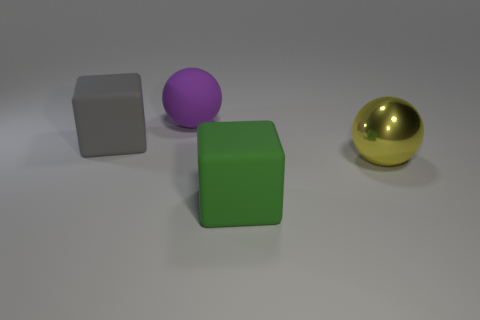There is a matte object that is on the right side of the gray block and in front of the large purple object; what color is it?
Your answer should be compact. Green. How big is the cube that is left of the big cube in front of the gray rubber block?
Offer a terse response. Large. Are there any large things that have the same color as the matte sphere?
Keep it short and to the point. No. Are there an equal number of big balls that are in front of the gray rubber block and metallic cylinders?
Keep it short and to the point. No. How many matte cubes are there?
Provide a short and direct response. 2. What is the shape of the big object that is in front of the big gray thing and left of the yellow shiny object?
Your answer should be compact. Cube. There is a rubber cube on the left side of the big purple rubber ball; does it have the same color as the large matte object to the right of the purple rubber sphere?
Your response must be concise. No. Are there any large brown cubes made of the same material as the yellow thing?
Give a very brief answer. No. Is the number of green rubber blocks that are to the left of the purple rubber thing the same as the number of purple objects that are in front of the large yellow ball?
Provide a short and direct response. Yes. What is the size of the cube to the left of the large matte sphere?
Make the answer very short. Large. 